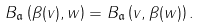Convert formula to latex. <formula><loc_0><loc_0><loc_500><loc_500>B _ { \mathfrak a } \left ( \beta ( v ) , w \right ) = B _ { \mathfrak a } \left ( v , \beta ( w ) \right ) .</formula> 